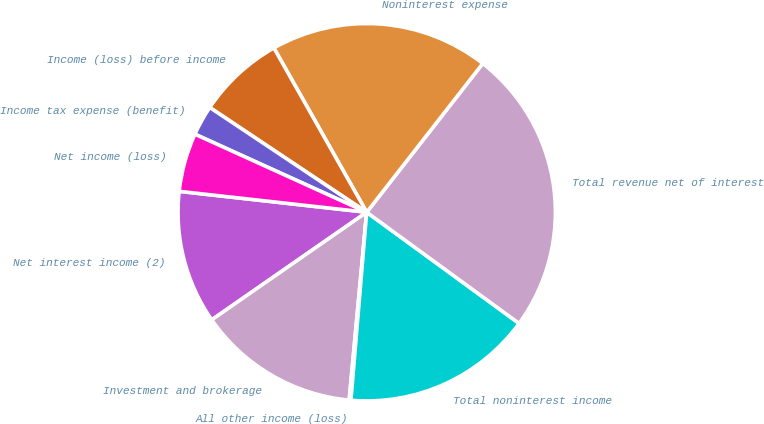<chart> <loc_0><loc_0><loc_500><loc_500><pie_chart><fcel>Net interest income (2)<fcel>Investment and brokerage<fcel>All other income (loss)<fcel>Total noninterest income<fcel>Total revenue net of interest<fcel>Noninterest expense<fcel>Income (loss) before income<fcel>Income tax expense (benefit)<fcel>Net income (loss)<nl><fcel>11.43%<fcel>13.86%<fcel>0.15%<fcel>16.3%<fcel>24.49%<fcel>18.73%<fcel>7.45%<fcel>2.58%<fcel>5.02%<nl></chart> 